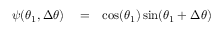Convert formula to latex. <formula><loc_0><loc_0><loc_500><loc_500>\begin{array} { r l r } { \psi ( \theta _ { 1 } , \Delta \theta ) } & = } & { \cos ( \theta _ { 1 } ) \sin ( \theta _ { 1 } + \Delta \theta ) } \end{array}</formula> 